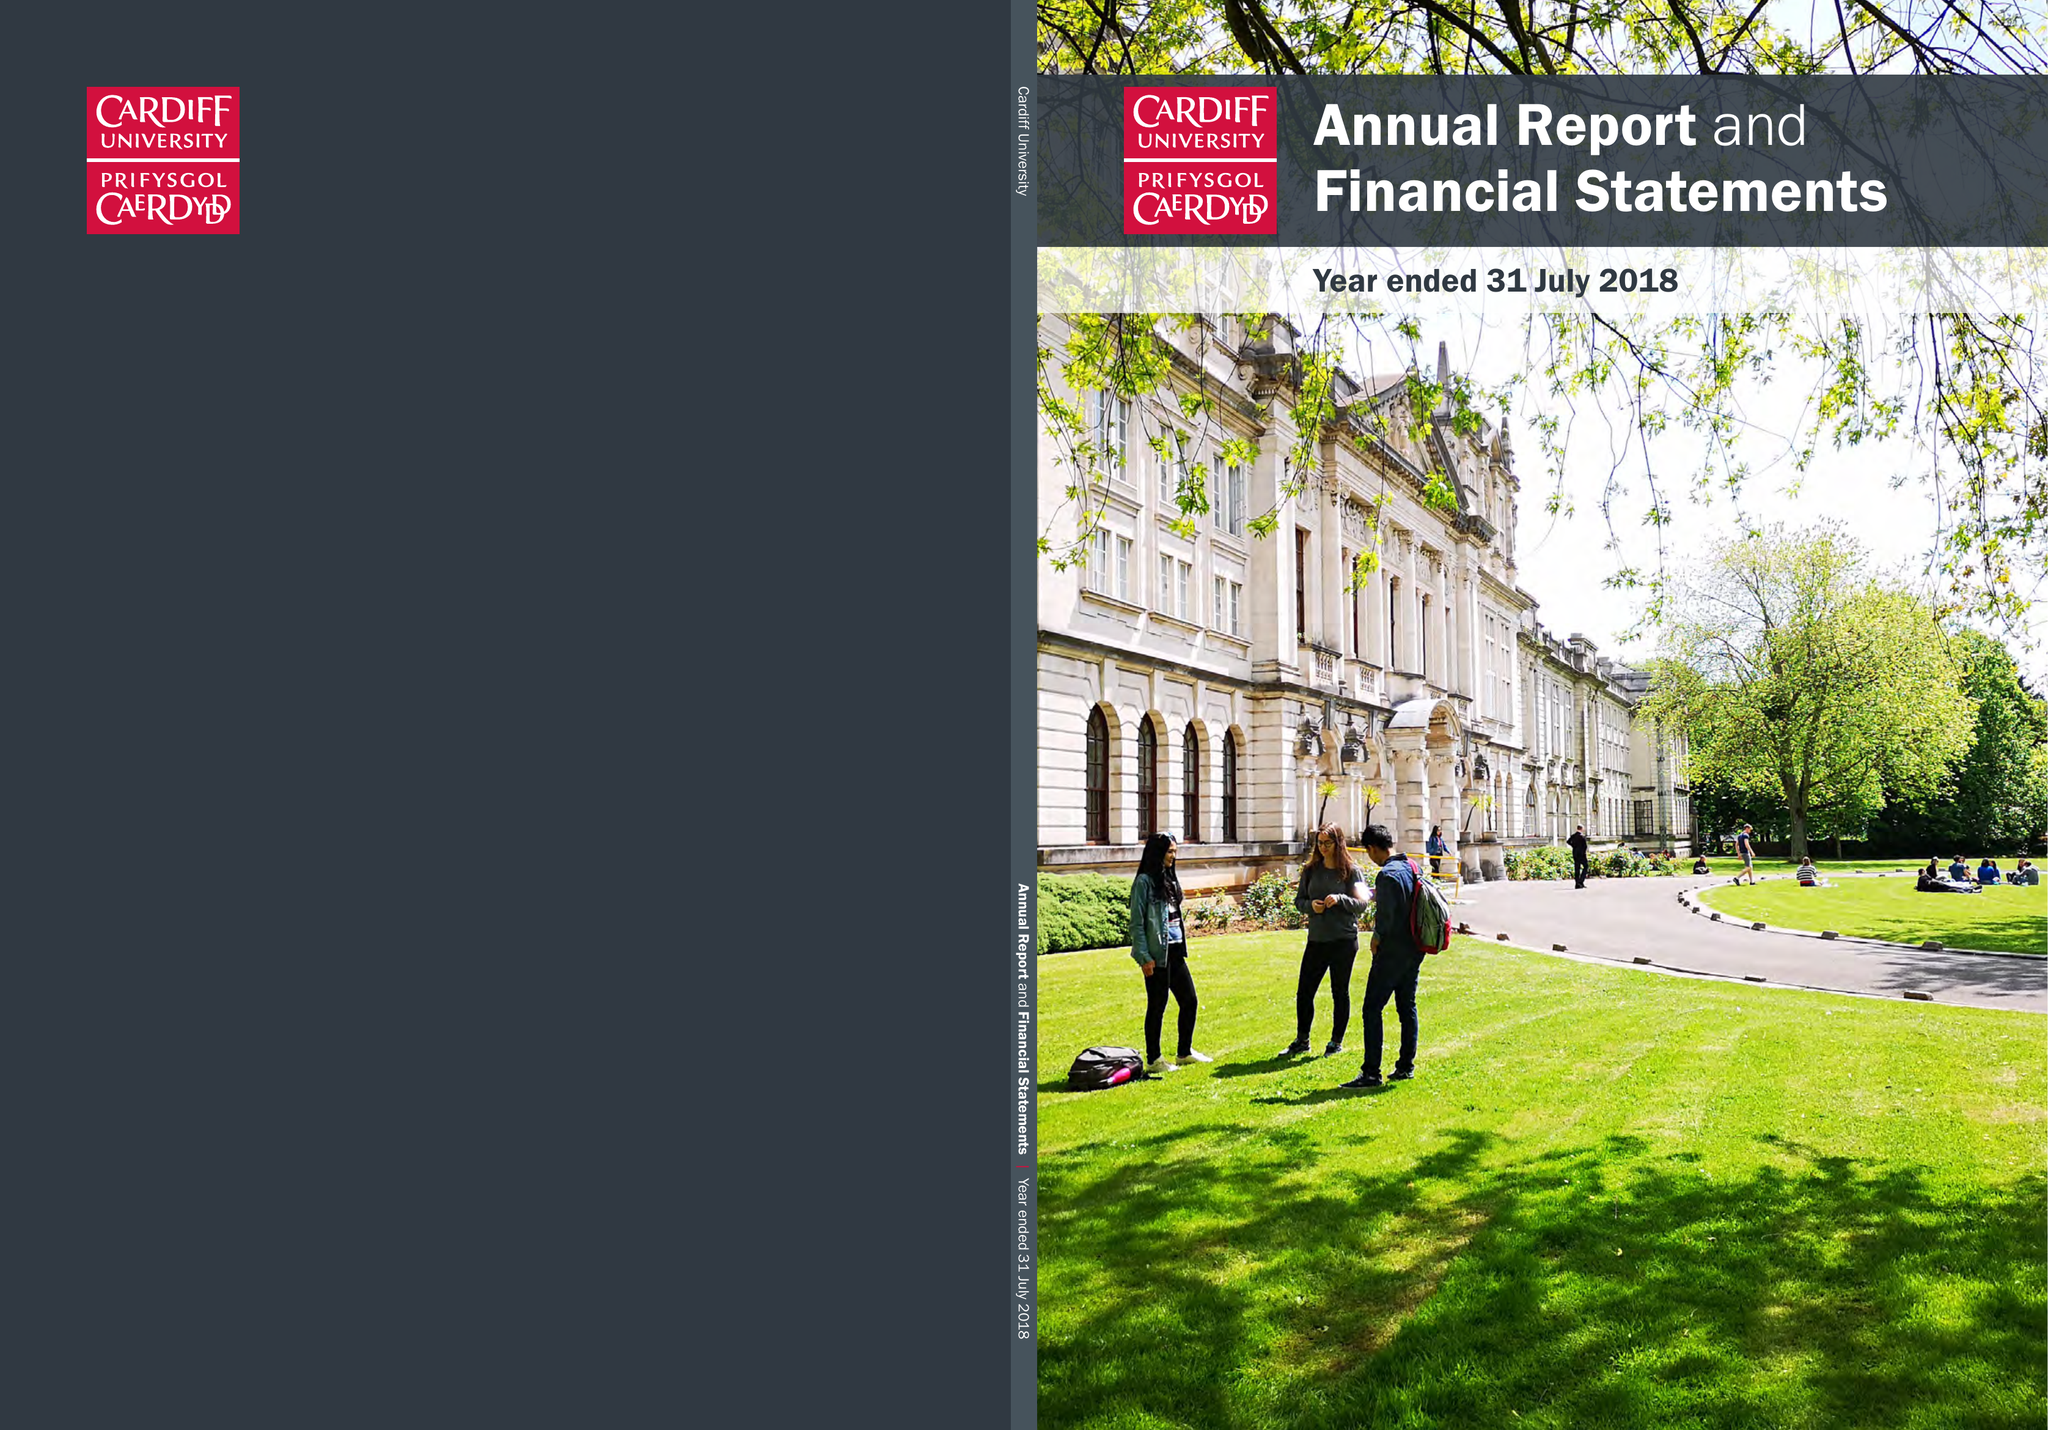What is the value for the report_date?
Answer the question using a single word or phrase. 2018-07-31 